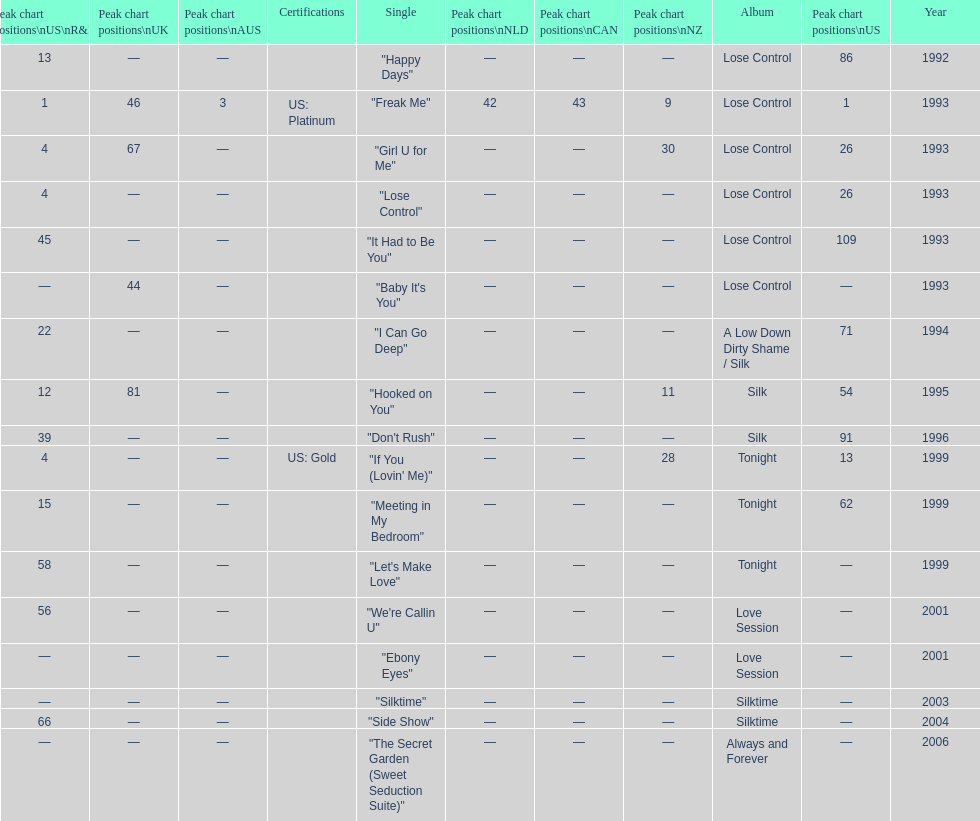Compare "i can go deep" with "don't rush". which was higher on the us and us r&b charts? "I Can Go Deep". 